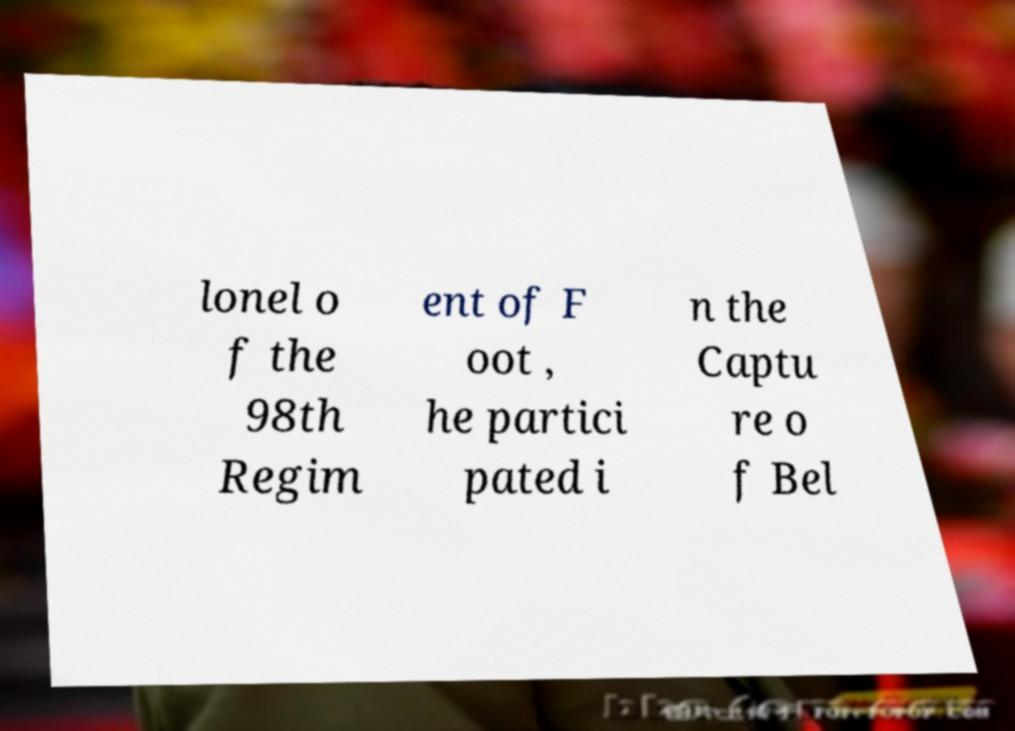For documentation purposes, I need the text within this image transcribed. Could you provide that? lonel o f the 98th Regim ent of F oot , he partici pated i n the Captu re o f Bel 